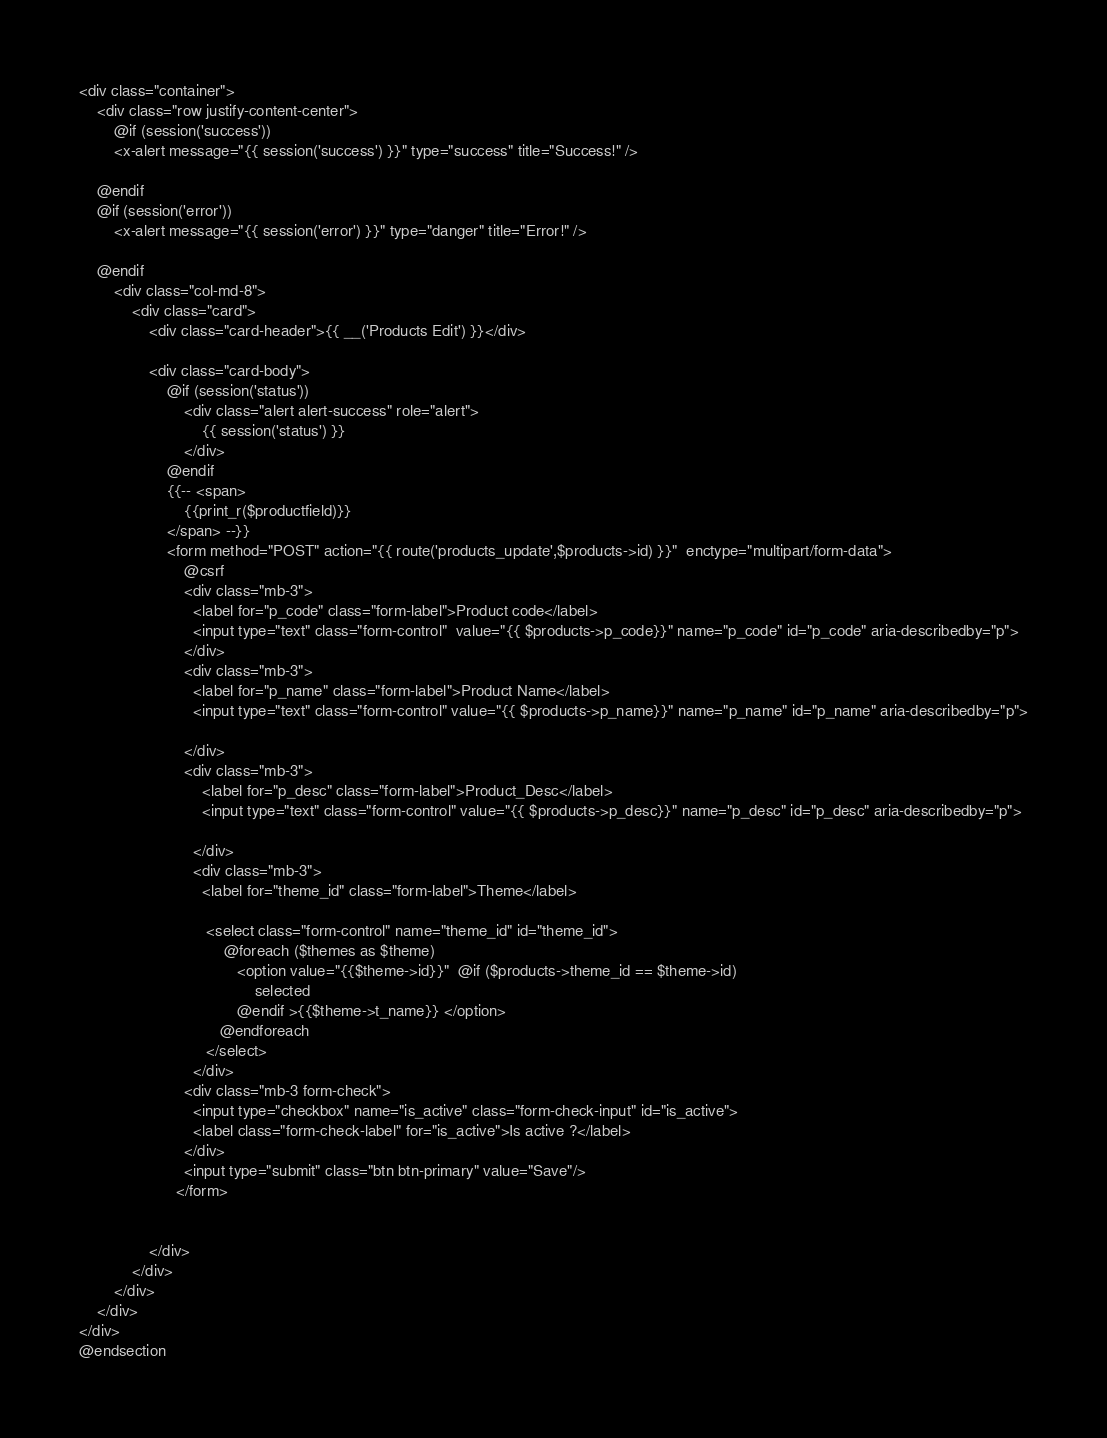Convert code to text. <code><loc_0><loc_0><loc_500><loc_500><_PHP_><div class="container">
    <div class="row justify-content-center">
        @if (session('success'))
        <x-alert message="{{ session('success') }}" type="success" title="Success!" />

    @endif
    @if (session('error'))
        <x-alert message="{{ session('error') }}" type="danger" title="Error!" />

    @endif
        <div class="col-md-8">
            <div class="card">
                <div class="card-header">{{ __('Products Edit') }}</div>

                <div class="card-body">
                    @if (session('status'))
                        <div class="alert alert-success" role="alert">
                            {{ session('status') }}
                        </div>
                    @endif
                    {{-- <span>
                        {{print_r($productfield)}}
                    </span> --}}
                    <form method="POST" action="{{ route('products_update',$products->id) }}"  enctype="multipart/form-data">
                        @csrf
                        <div class="mb-3">
                          <label for="p_code" class="form-label">Product code</label>
                          <input type="text" class="form-control"  value="{{ $products->p_code}}" name="p_code" id="p_code" aria-describedby="p">
                        </div>
                        <div class="mb-3">
                          <label for="p_name" class="form-label">Product Name</label>
                          <input type="text" class="form-control" value="{{ $products->p_name}}" name="p_name" id="p_name" aria-describedby="p">

                        </div>
                        <div class="mb-3">
                            <label for="p_desc" class="form-label">Product_Desc</label>
                            <input type="text" class="form-control" value="{{ $products->p_desc}}" name="p_desc" id="p_desc" aria-describedby="p">

                          </div>
                          <div class="mb-3">
                            <label for="theme_id" class="form-label">Theme</label>

                             <select class="form-control" name="theme_id" id="theme_id">
                                 @foreach ($themes as $theme)
                                    <option value="{{$theme->id}}"  @if ($products->theme_id == $theme->id)
                                        selected
                                    @endif >{{$theme->t_name}} </option>
                                @endforeach
                             </select>
                          </div>
                        <div class="mb-3 form-check">
                          <input type="checkbox" name="is_active" class="form-check-input" id="is_active">
                          <label class="form-check-label" for="is_active">Is active ?</label>
                        </div>
                        <input type="submit" class="btn btn-primary" value="Save"/>
                      </form>


                </div>
            </div>
        </div>
    </div>
</div>
@endsection
</code> 